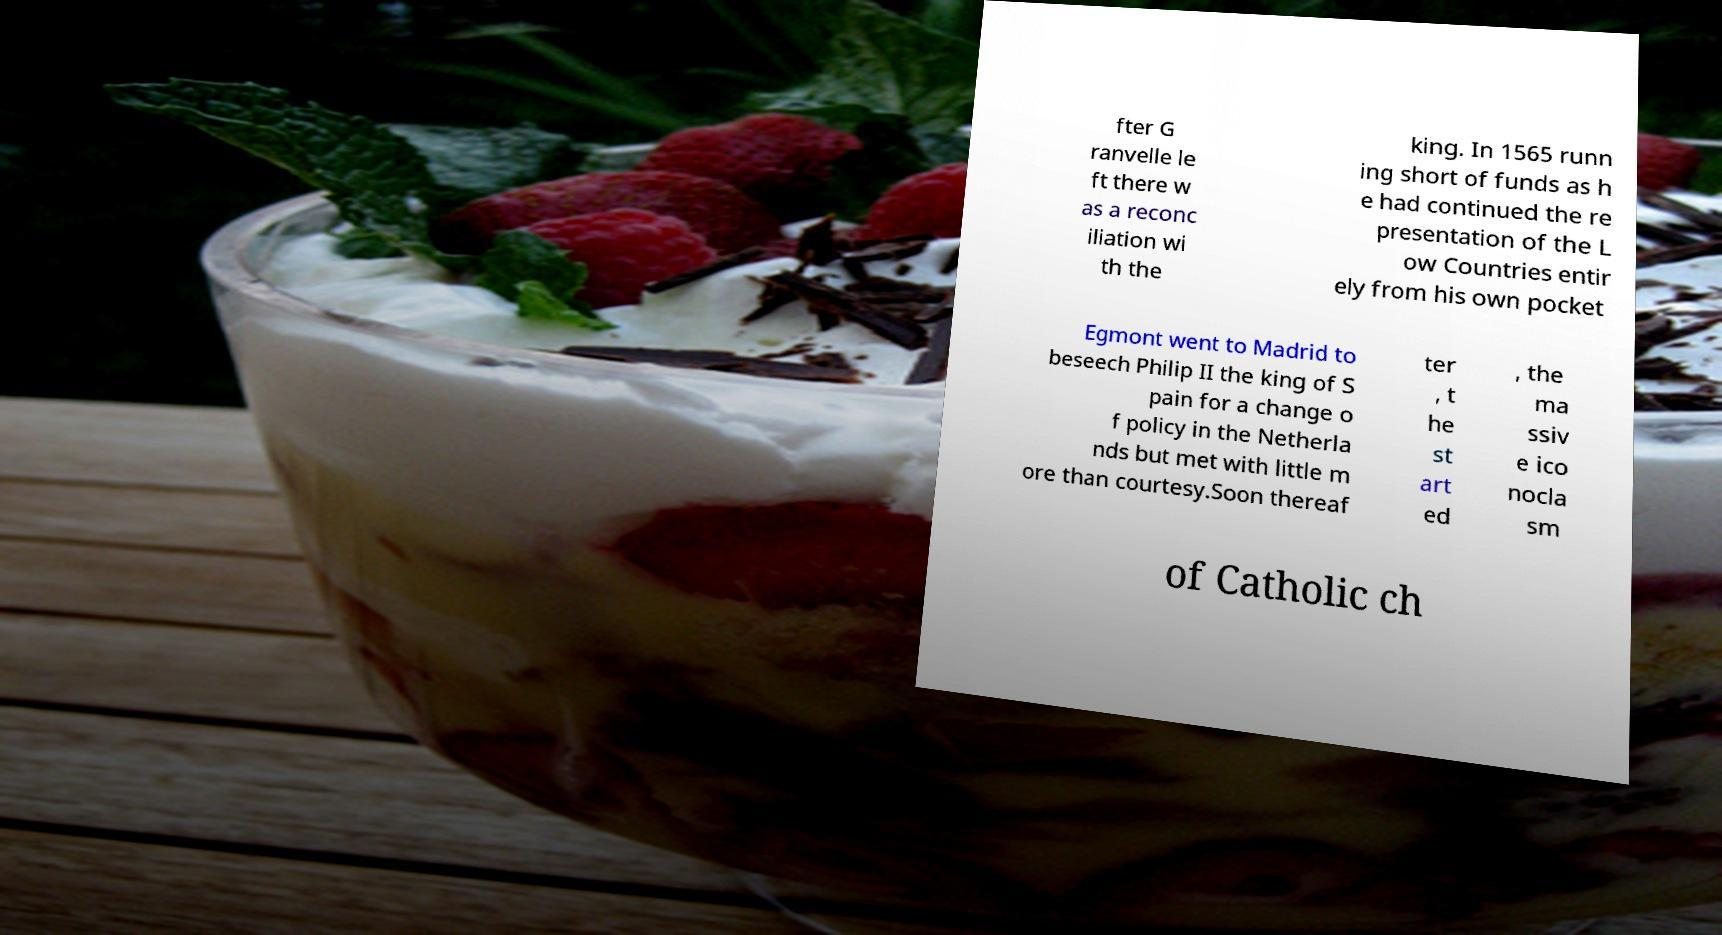Can you accurately transcribe the text from the provided image for me? fter G ranvelle le ft there w as a reconc iliation wi th the king. In 1565 runn ing short of funds as h e had continued the re presentation of the L ow Countries entir ely from his own pocket Egmont went to Madrid to beseech Philip II the king of S pain for a change o f policy in the Netherla nds but met with little m ore than courtesy.Soon thereaf ter , t he st art ed , the ma ssiv e ico nocla sm of Catholic ch 